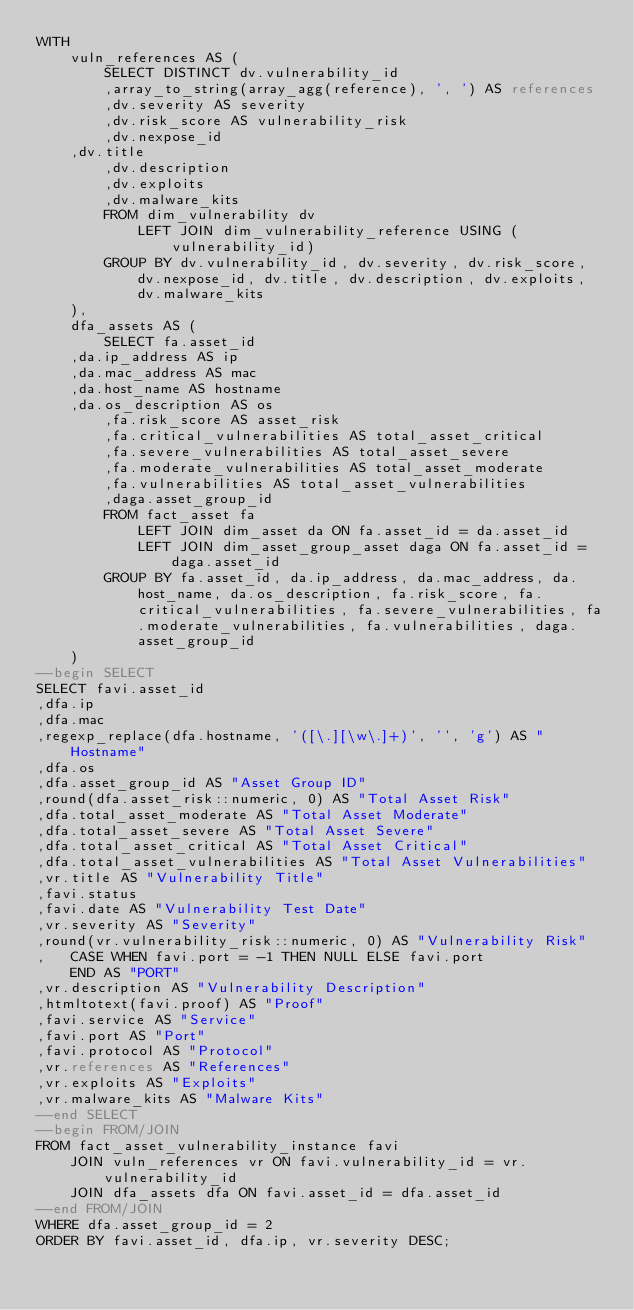<code> <loc_0><loc_0><loc_500><loc_500><_SQL_>WITH
    vuln_references AS (
        SELECT DISTINCT dv.vulnerability_id
        ,array_to_string(array_agg(reference), ', ') AS references
        ,dv.severity AS severity
        ,dv.risk_score AS vulnerability_risk
        ,dv.nexpose_id
		,dv.title
        ,dv.description
        ,dv.exploits
        ,dv.malware_kits
        FROM dim_vulnerability dv
            LEFT JOIN dim_vulnerability_reference USING (vulnerability_id)
        GROUP BY dv.vulnerability_id, dv.severity, dv.risk_score, dv.nexpose_id, dv.title, dv.description, dv.exploits, dv.malware_kits
    ),
    dfa_assets AS (
        SELECT fa.asset_id
		,da.ip_address AS ip
		,da.mac_address AS mac
		,da.host_name AS hostname
		,da.os_description AS os
        ,fa.risk_score AS asset_risk
        ,fa.critical_vulnerabilities AS total_asset_critical
        ,fa.severe_vulnerabilities AS total_asset_severe
        ,fa.moderate_vulnerabilities AS total_asset_moderate
        ,fa.vulnerabilities AS total_asset_vulnerabilities
        ,daga.asset_group_id
        FROM fact_asset fa
            LEFT JOIN dim_asset da ON fa.asset_id = da.asset_id
            LEFT JOIN dim_asset_group_asset daga ON fa.asset_id = daga.asset_id
        GROUP BY fa.asset_id, da.ip_address, da.mac_address, da.host_name, da.os_description, fa.risk_score, fa.critical_vulnerabilities, fa.severe_vulnerabilities, fa.moderate_vulnerabilities, fa.vulnerabilities, daga.asset_group_id
    )
--begin SELECT
SELECT favi.asset_id
,dfa.ip
,dfa.mac
,regexp_replace(dfa.hostname, '([\.][\w\.]+)', '', 'g') AS "Hostname"
,dfa.os
,dfa.asset_group_id AS "Asset Group ID"
,round(dfa.asset_risk::numeric, 0) AS "Total Asset Risk"
,dfa.total_asset_moderate AS "Total Asset Moderate"
,dfa.total_asset_severe AS "Total Asset Severe"
,dfa.total_asset_critical AS "Total Asset Critical"
,dfa.total_asset_vulnerabilities AS "Total Asset Vulnerabilities"
,vr.title AS "Vulnerability Title"
,favi.status
,favi.date AS "Vulnerability Test Date"
,vr.severity AS "Severity"
,round(vr.vulnerability_risk::numeric, 0) AS "Vulnerability Risk"
,   CASE WHEN favi.port = -1 THEN NULL ELSE favi.port
    END AS "PORT"
,vr.description AS "Vulnerability Description"
,htmltotext(favi.proof) AS "Proof"
,favi.service AS "Service"
,favi.port AS "Port"
,favi.protocol AS "Protocol"
,vr.references AS "References"
,vr.exploits AS "Exploits"
,vr.malware_kits AS "Malware Kits"
--end SELECT
--begin FROM/JOIN
FROM fact_asset_vulnerability_instance favi
    JOIN vuln_references vr ON favi.vulnerability_id = vr.vulnerability_id
    JOIN dfa_assets dfa ON favi.asset_id = dfa.asset_id
--end FROM/JOIN
WHERE dfa.asset_group_id = 2
ORDER BY favi.asset_id, dfa.ip, vr.severity DESC;
</code> 